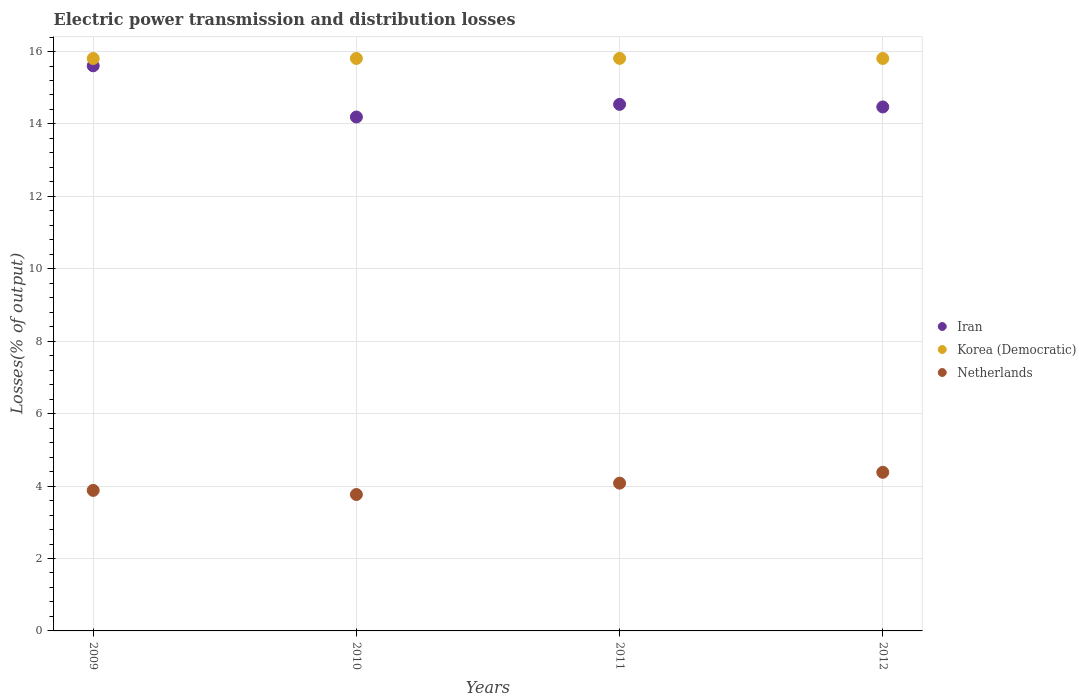How many different coloured dotlines are there?
Make the answer very short. 3. What is the electric power transmission and distribution losses in Iran in 2010?
Your response must be concise. 14.19. Across all years, what is the maximum electric power transmission and distribution losses in Iran?
Keep it short and to the point. 15.61. Across all years, what is the minimum electric power transmission and distribution losses in Korea (Democratic)?
Your response must be concise. 15.81. What is the total electric power transmission and distribution losses in Netherlands in the graph?
Your response must be concise. 16.11. What is the difference between the electric power transmission and distribution losses in Netherlands in 2009 and that in 2012?
Provide a succinct answer. -0.5. What is the difference between the electric power transmission and distribution losses in Iran in 2011 and the electric power transmission and distribution losses in Korea (Democratic) in 2012?
Give a very brief answer. -1.27. What is the average electric power transmission and distribution losses in Netherlands per year?
Ensure brevity in your answer.  4.03. In the year 2012, what is the difference between the electric power transmission and distribution losses in Iran and electric power transmission and distribution losses in Korea (Democratic)?
Keep it short and to the point. -1.34. In how many years, is the electric power transmission and distribution losses in Netherlands greater than 15.6 %?
Your answer should be compact. 0. What is the ratio of the electric power transmission and distribution losses in Korea (Democratic) in 2009 to that in 2011?
Provide a short and direct response. 1. Is the electric power transmission and distribution losses in Netherlands in 2010 less than that in 2011?
Your answer should be compact. Yes. Is the difference between the electric power transmission and distribution losses in Iran in 2010 and 2012 greater than the difference between the electric power transmission and distribution losses in Korea (Democratic) in 2010 and 2012?
Offer a terse response. No. What is the difference between the highest and the second highest electric power transmission and distribution losses in Netherlands?
Provide a succinct answer. 0.3. What is the difference between the highest and the lowest electric power transmission and distribution losses in Netherlands?
Your answer should be very brief. 0.61. In how many years, is the electric power transmission and distribution losses in Iran greater than the average electric power transmission and distribution losses in Iran taken over all years?
Ensure brevity in your answer.  1. Is the sum of the electric power transmission and distribution losses in Iran in 2010 and 2011 greater than the maximum electric power transmission and distribution losses in Netherlands across all years?
Your answer should be compact. Yes. Is it the case that in every year, the sum of the electric power transmission and distribution losses in Iran and electric power transmission and distribution losses in Netherlands  is greater than the electric power transmission and distribution losses in Korea (Democratic)?
Your answer should be compact. Yes. Does the electric power transmission and distribution losses in Iran monotonically increase over the years?
Give a very brief answer. No. How many years are there in the graph?
Your response must be concise. 4. What is the difference between two consecutive major ticks on the Y-axis?
Your response must be concise. 2. Are the values on the major ticks of Y-axis written in scientific E-notation?
Offer a terse response. No. Does the graph contain grids?
Give a very brief answer. Yes. Where does the legend appear in the graph?
Provide a short and direct response. Center right. What is the title of the graph?
Ensure brevity in your answer.  Electric power transmission and distribution losses. What is the label or title of the Y-axis?
Offer a very short reply. Losses(% of output). What is the Losses(% of output) in Iran in 2009?
Your answer should be compact. 15.61. What is the Losses(% of output) in Korea (Democratic) in 2009?
Ensure brevity in your answer.  15.81. What is the Losses(% of output) in Netherlands in 2009?
Ensure brevity in your answer.  3.88. What is the Losses(% of output) of Iran in 2010?
Your answer should be very brief. 14.19. What is the Losses(% of output) in Korea (Democratic) in 2010?
Provide a short and direct response. 15.81. What is the Losses(% of output) in Netherlands in 2010?
Your answer should be compact. 3.77. What is the Losses(% of output) of Iran in 2011?
Your answer should be very brief. 14.54. What is the Losses(% of output) in Korea (Democratic) in 2011?
Provide a short and direct response. 15.81. What is the Losses(% of output) in Netherlands in 2011?
Keep it short and to the point. 4.08. What is the Losses(% of output) in Iran in 2012?
Your answer should be very brief. 14.47. What is the Losses(% of output) in Korea (Democratic) in 2012?
Make the answer very short. 15.81. What is the Losses(% of output) of Netherlands in 2012?
Your answer should be compact. 4.38. Across all years, what is the maximum Losses(% of output) in Iran?
Your answer should be very brief. 15.61. Across all years, what is the maximum Losses(% of output) of Korea (Democratic)?
Your response must be concise. 15.81. Across all years, what is the maximum Losses(% of output) of Netherlands?
Your answer should be compact. 4.38. Across all years, what is the minimum Losses(% of output) of Iran?
Your answer should be very brief. 14.19. Across all years, what is the minimum Losses(% of output) of Korea (Democratic)?
Ensure brevity in your answer.  15.81. Across all years, what is the minimum Losses(% of output) of Netherlands?
Give a very brief answer. 3.77. What is the total Losses(% of output) in Iran in the graph?
Give a very brief answer. 58.81. What is the total Losses(% of output) of Korea (Democratic) in the graph?
Provide a succinct answer. 63.24. What is the total Losses(% of output) in Netherlands in the graph?
Your answer should be very brief. 16.11. What is the difference between the Losses(% of output) of Iran in 2009 and that in 2010?
Offer a terse response. 1.41. What is the difference between the Losses(% of output) of Korea (Democratic) in 2009 and that in 2010?
Keep it short and to the point. -0. What is the difference between the Losses(% of output) of Netherlands in 2009 and that in 2010?
Give a very brief answer. 0.11. What is the difference between the Losses(% of output) of Iran in 2009 and that in 2011?
Provide a short and direct response. 1.06. What is the difference between the Losses(% of output) in Korea (Democratic) in 2009 and that in 2011?
Provide a succinct answer. -0. What is the difference between the Losses(% of output) of Netherlands in 2009 and that in 2011?
Your answer should be compact. -0.2. What is the difference between the Losses(% of output) in Iran in 2009 and that in 2012?
Your response must be concise. 1.14. What is the difference between the Losses(% of output) of Korea (Democratic) in 2009 and that in 2012?
Your response must be concise. -0. What is the difference between the Losses(% of output) in Netherlands in 2009 and that in 2012?
Your answer should be very brief. -0.5. What is the difference between the Losses(% of output) in Iran in 2010 and that in 2011?
Your answer should be very brief. -0.35. What is the difference between the Losses(% of output) in Korea (Democratic) in 2010 and that in 2011?
Offer a very short reply. -0. What is the difference between the Losses(% of output) of Netherlands in 2010 and that in 2011?
Provide a succinct answer. -0.31. What is the difference between the Losses(% of output) in Iran in 2010 and that in 2012?
Keep it short and to the point. -0.28. What is the difference between the Losses(% of output) in Netherlands in 2010 and that in 2012?
Keep it short and to the point. -0.61. What is the difference between the Losses(% of output) of Iran in 2011 and that in 2012?
Ensure brevity in your answer.  0.07. What is the difference between the Losses(% of output) of Korea (Democratic) in 2011 and that in 2012?
Make the answer very short. 0. What is the difference between the Losses(% of output) of Netherlands in 2011 and that in 2012?
Your response must be concise. -0.3. What is the difference between the Losses(% of output) in Iran in 2009 and the Losses(% of output) in Korea (Democratic) in 2010?
Ensure brevity in your answer.  -0.2. What is the difference between the Losses(% of output) of Iran in 2009 and the Losses(% of output) of Netherlands in 2010?
Ensure brevity in your answer.  11.84. What is the difference between the Losses(% of output) in Korea (Democratic) in 2009 and the Losses(% of output) in Netherlands in 2010?
Offer a very short reply. 12.04. What is the difference between the Losses(% of output) in Iran in 2009 and the Losses(% of output) in Korea (Democratic) in 2011?
Provide a short and direct response. -0.21. What is the difference between the Losses(% of output) in Iran in 2009 and the Losses(% of output) in Netherlands in 2011?
Your response must be concise. 11.53. What is the difference between the Losses(% of output) of Korea (Democratic) in 2009 and the Losses(% of output) of Netherlands in 2011?
Offer a terse response. 11.73. What is the difference between the Losses(% of output) in Iran in 2009 and the Losses(% of output) in Korea (Democratic) in 2012?
Keep it short and to the point. -0.2. What is the difference between the Losses(% of output) of Iran in 2009 and the Losses(% of output) of Netherlands in 2012?
Your response must be concise. 11.23. What is the difference between the Losses(% of output) of Korea (Democratic) in 2009 and the Losses(% of output) of Netherlands in 2012?
Provide a succinct answer. 11.43. What is the difference between the Losses(% of output) in Iran in 2010 and the Losses(% of output) in Korea (Democratic) in 2011?
Provide a succinct answer. -1.62. What is the difference between the Losses(% of output) of Iran in 2010 and the Losses(% of output) of Netherlands in 2011?
Offer a terse response. 10.11. What is the difference between the Losses(% of output) of Korea (Democratic) in 2010 and the Losses(% of output) of Netherlands in 2011?
Your response must be concise. 11.73. What is the difference between the Losses(% of output) of Iran in 2010 and the Losses(% of output) of Korea (Democratic) in 2012?
Your answer should be very brief. -1.62. What is the difference between the Losses(% of output) in Iran in 2010 and the Losses(% of output) in Netherlands in 2012?
Keep it short and to the point. 9.81. What is the difference between the Losses(% of output) of Korea (Democratic) in 2010 and the Losses(% of output) of Netherlands in 2012?
Your response must be concise. 11.43. What is the difference between the Losses(% of output) in Iran in 2011 and the Losses(% of output) in Korea (Democratic) in 2012?
Your response must be concise. -1.27. What is the difference between the Losses(% of output) in Iran in 2011 and the Losses(% of output) in Netherlands in 2012?
Make the answer very short. 10.16. What is the difference between the Losses(% of output) of Korea (Democratic) in 2011 and the Losses(% of output) of Netherlands in 2012?
Your answer should be very brief. 11.43. What is the average Losses(% of output) of Iran per year?
Give a very brief answer. 14.7. What is the average Losses(% of output) of Korea (Democratic) per year?
Your answer should be very brief. 15.81. What is the average Losses(% of output) of Netherlands per year?
Give a very brief answer. 4.03. In the year 2009, what is the difference between the Losses(% of output) in Iran and Losses(% of output) in Korea (Democratic)?
Your response must be concise. -0.2. In the year 2009, what is the difference between the Losses(% of output) of Iran and Losses(% of output) of Netherlands?
Give a very brief answer. 11.72. In the year 2009, what is the difference between the Losses(% of output) of Korea (Democratic) and Losses(% of output) of Netherlands?
Ensure brevity in your answer.  11.93. In the year 2010, what is the difference between the Losses(% of output) in Iran and Losses(% of output) in Korea (Democratic)?
Provide a short and direct response. -1.62. In the year 2010, what is the difference between the Losses(% of output) of Iran and Losses(% of output) of Netherlands?
Ensure brevity in your answer.  10.43. In the year 2010, what is the difference between the Losses(% of output) in Korea (Democratic) and Losses(% of output) in Netherlands?
Provide a short and direct response. 12.04. In the year 2011, what is the difference between the Losses(% of output) of Iran and Losses(% of output) of Korea (Democratic)?
Ensure brevity in your answer.  -1.27. In the year 2011, what is the difference between the Losses(% of output) of Iran and Losses(% of output) of Netherlands?
Provide a succinct answer. 10.46. In the year 2011, what is the difference between the Losses(% of output) in Korea (Democratic) and Losses(% of output) in Netherlands?
Provide a short and direct response. 11.73. In the year 2012, what is the difference between the Losses(% of output) of Iran and Losses(% of output) of Korea (Democratic)?
Make the answer very short. -1.34. In the year 2012, what is the difference between the Losses(% of output) in Iran and Losses(% of output) in Netherlands?
Offer a very short reply. 10.09. In the year 2012, what is the difference between the Losses(% of output) in Korea (Democratic) and Losses(% of output) in Netherlands?
Ensure brevity in your answer.  11.43. What is the ratio of the Losses(% of output) in Iran in 2009 to that in 2010?
Offer a terse response. 1.1. What is the ratio of the Losses(% of output) of Netherlands in 2009 to that in 2010?
Give a very brief answer. 1.03. What is the ratio of the Losses(% of output) in Iran in 2009 to that in 2011?
Your response must be concise. 1.07. What is the ratio of the Losses(% of output) in Netherlands in 2009 to that in 2011?
Offer a very short reply. 0.95. What is the ratio of the Losses(% of output) in Iran in 2009 to that in 2012?
Make the answer very short. 1.08. What is the ratio of the Losses(% of output) in Korea (Democratic) in 2009 to that in 2012?
Give a very brief answer. 1. What is the ratio of the Losses(% of output) in Netherlands in 2009 to that in 2012?
Offer a very short reply. 0.89. What is the ratio of the Losses(% of output) of Iran in 2010 to that in 2011?
Offer a terse response. 0.98. What is the ratio of the Losses(% of output) of Netherlands in 2010 to that in 2011?
Ensure brevity in your answer.  0.92. What is the ratio of the Losses(% of output) in Iran in 2010 to that in 2012?
Your answer should be compact. 0.98. What is the ratio of the Losses(% of output) in Netherlands in 2010 to that in 2012?
Keep it short and to the point. 0.86. What is the ratio of the Losses(% of output) in Iran in 2011 to that in 2012?
Offer a terse response. 1. What is the ratio of the Losses(% of output) in Korea (Democratic) in 2011 to that in 2012?
Your response must be concise. 1. What is the ratio of the Losses(% of output) of Netherlands in 2011 to that in 2012?
Your answer should be very brief. 0.93. What is the difference between the highest and the second highest Losses(% of output) in Iran?
Your answer should be very brief. 1.06. What is the difference between the highest and the second highest Losses(% of output) in Korea (Democratic)?
Ensure brevity in your answer.  0. What is the difference between the highest and the second highest Losses(% of output) in Netherlands?
Your answer should be compact. 0.3. What is the difference between the highest and the lowest Losses(% of output) of Iran?
Your response must be concise. 1.41. What is the difference between the highest and the lowest Losses(% of output) in Korea (Democratic)?
Provide a succinct answer. 0. What is the difference between the highest and the lowest Losses(% of output) of Netherlands?
Offer a very short reply. 0.61. 